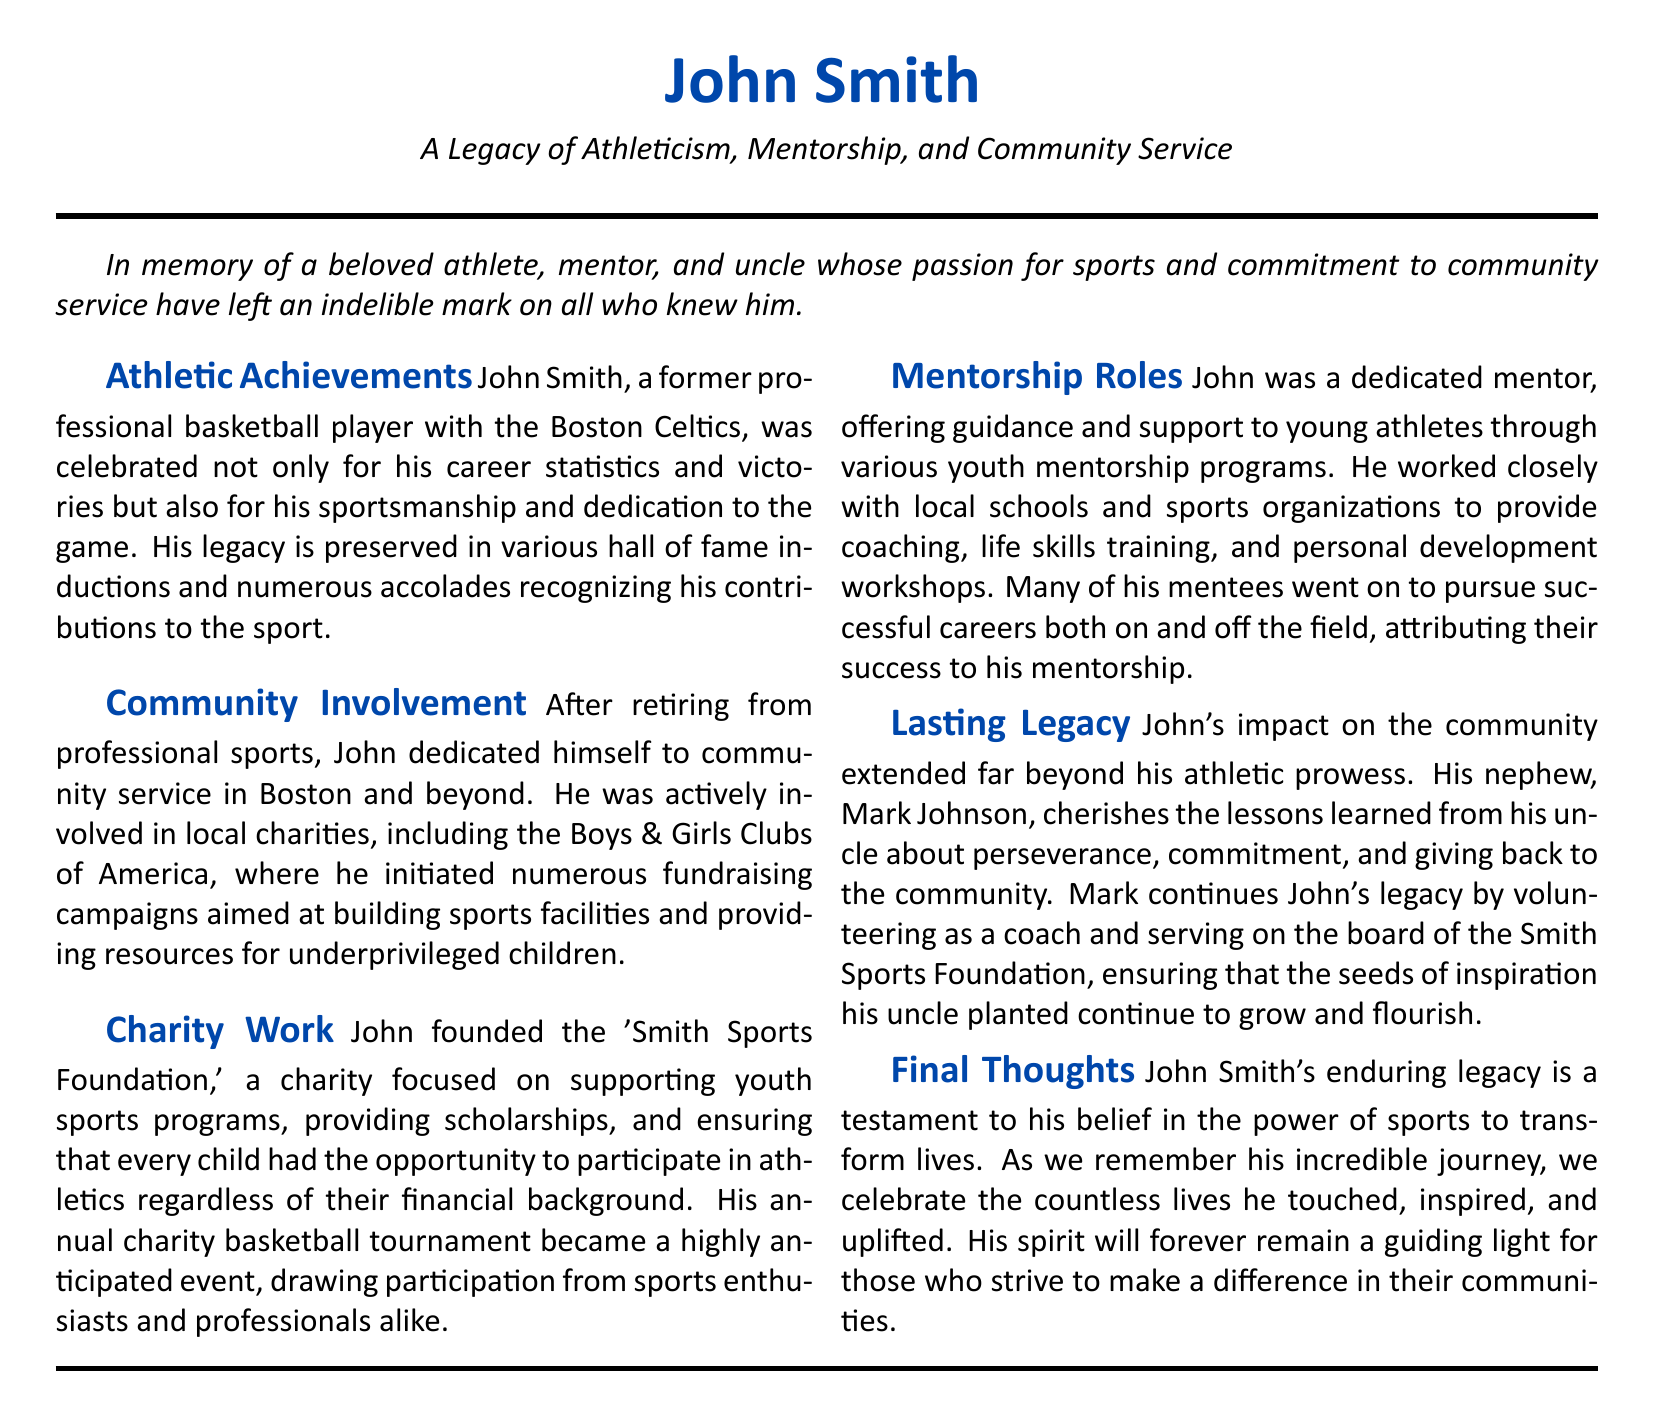What was John Smith's profession? The document states that John Smith was a former professional basketball player with the Boston Celtics.
Answer: professional basketball player What charity did John Smith found? According to the document, John founded the 'Smith Sports Foundation.'
Answer: Smith Sports Foundation How did John contribute to youth sports programs? The document mentions that he provided scholarships and ensured opportunities for children to participate in athletics.
Answer: scholarships and opportunities Who is John Smith's nephew? The document specifies that his nephew is Mark Johnson.
Answer: Mark Johnson What did John establish to raise funds for sports facilities? The document states that he initiated numerous fundraising campaigns aimed at building sports facilities.
Answer: fundraising campaigns What was one significant event organized by John Smith? The document notes that his annual charity basketball tournament became a highly anticipated event.
Answer: annual charity basketball tournament What impact did John have on his mentees? The document highlights that many of his mentees went on to pursue successful careers, attributing their success to his mentorship.
Answer: successful careers Which community organization was John involved with? The document mentions his active involvement with the Boys & Girls Clubs of America.
Answer: Boys & Girls Clubs of America 